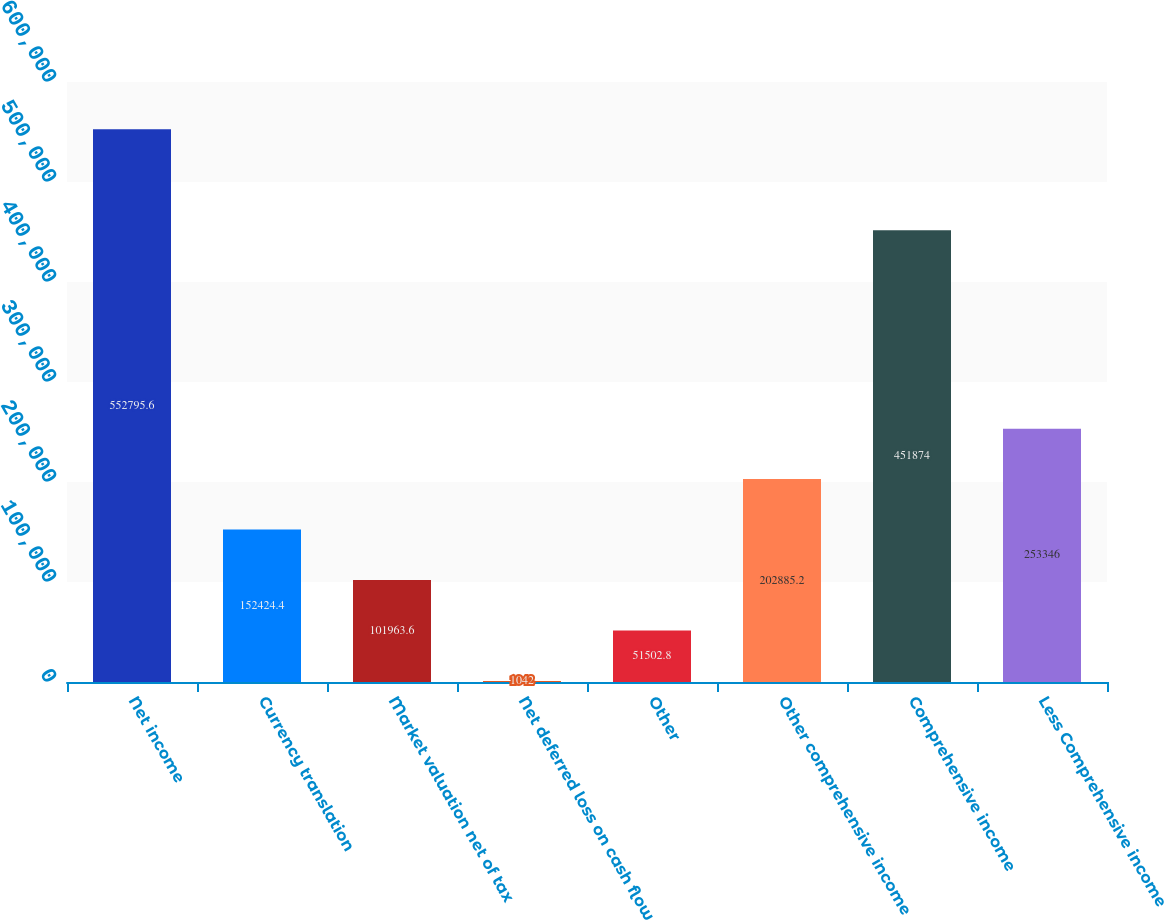<chart> <loc_0><loc_0><loc_500><loc_500><bar_chart><fcel>Net income<fcel>Currency translation<fcel>Market valuation net of tax<fcel>Net deferred loss on cash flow<fcel>Other<fcel>Other comprehensive income<fcel>Comprehensive income<fcel>Less Comprehensive income<nl><fcel>552796<fcel>152424<fcel>101964<fcel>1042<fcel>51502.8<fcel>202885<fcel>451874<fcel>253346<nl></chart> 